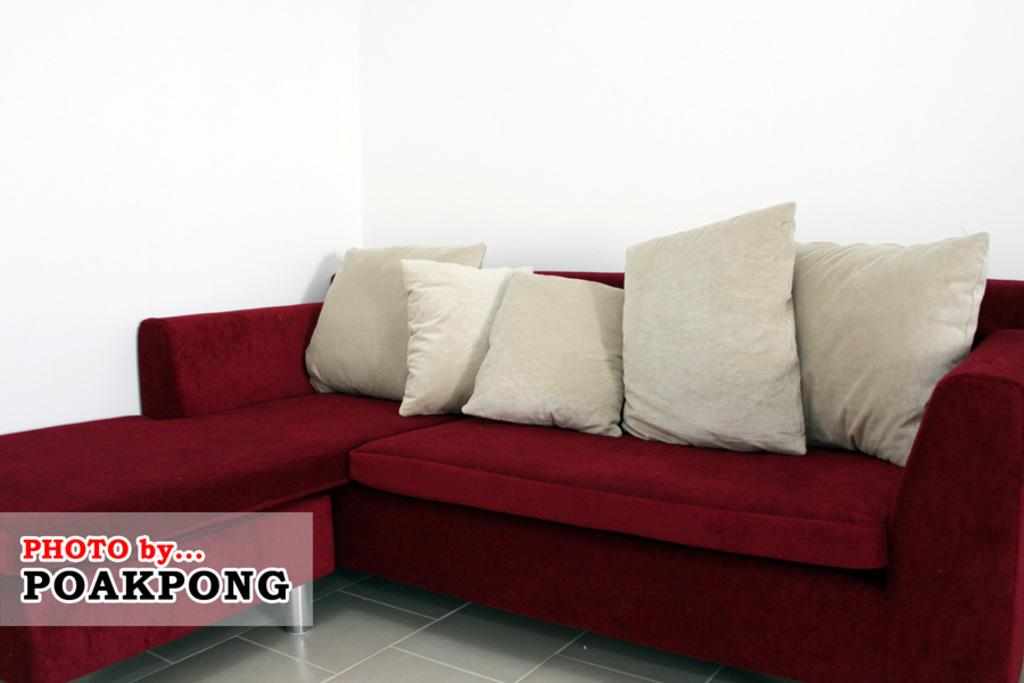What color is the sofa in the image? The sofa in the image is red. Where is the red sofa located in the image? The red sofa is towards the right side. What is placed on the red sofa? There are cream pillows on the red sofa. How are the cream pillows arranged on the red sofa? The cream pillows are grouped together. What can be found in the bottom left corner of the image? There is some text in the bottom left corner of the image. What type of drawer can be seen in the image? There is no drawer present in the image. What is the front of the red sofa like in the image? The image does not show the front of the red sofa, only the side with the cream pillows. 